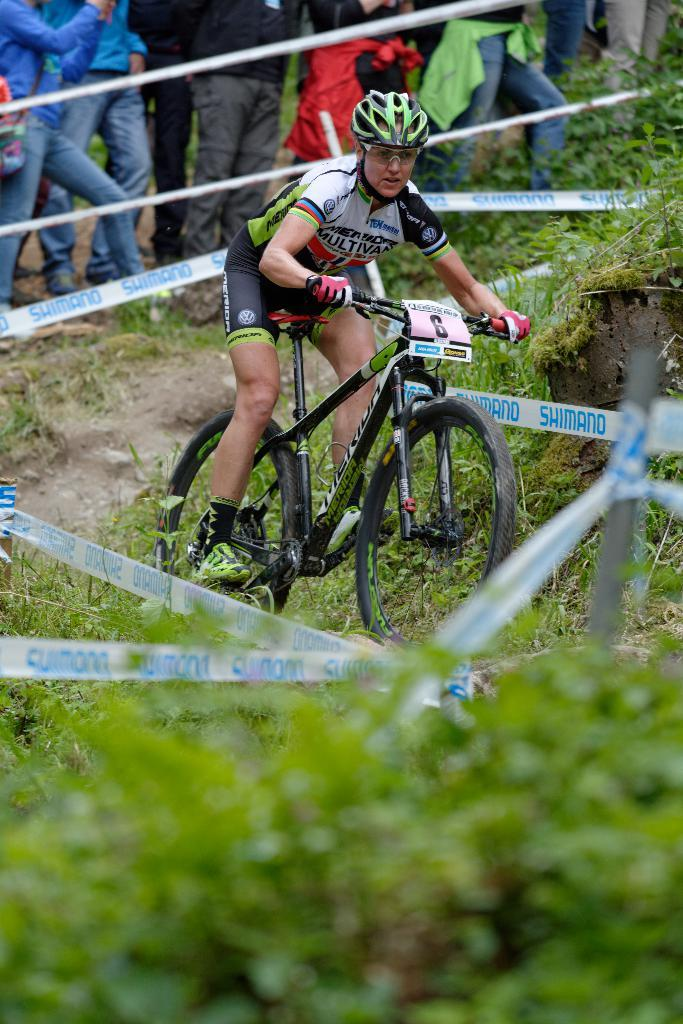What is the man in the image doing? The man is riding a bicycle in the image. What safety precaution is the man taking while riding the bicycle? The man is wearing a helmet. Can you describe the people behind the man in the image? There are people standing behind the man in the image. What type of vegetation can be seen in the image? Plants and grass are visible in the image. What scientific experiment is being conducted by the group in the image? There is no group or scientific experiment present in the image; it features a man riding a bicycle with people standing behind him. How does the man control the bicycle in the image? The man controls the bicycle by pedaling and steering, but this question is not directly answerable from the provided facts. 